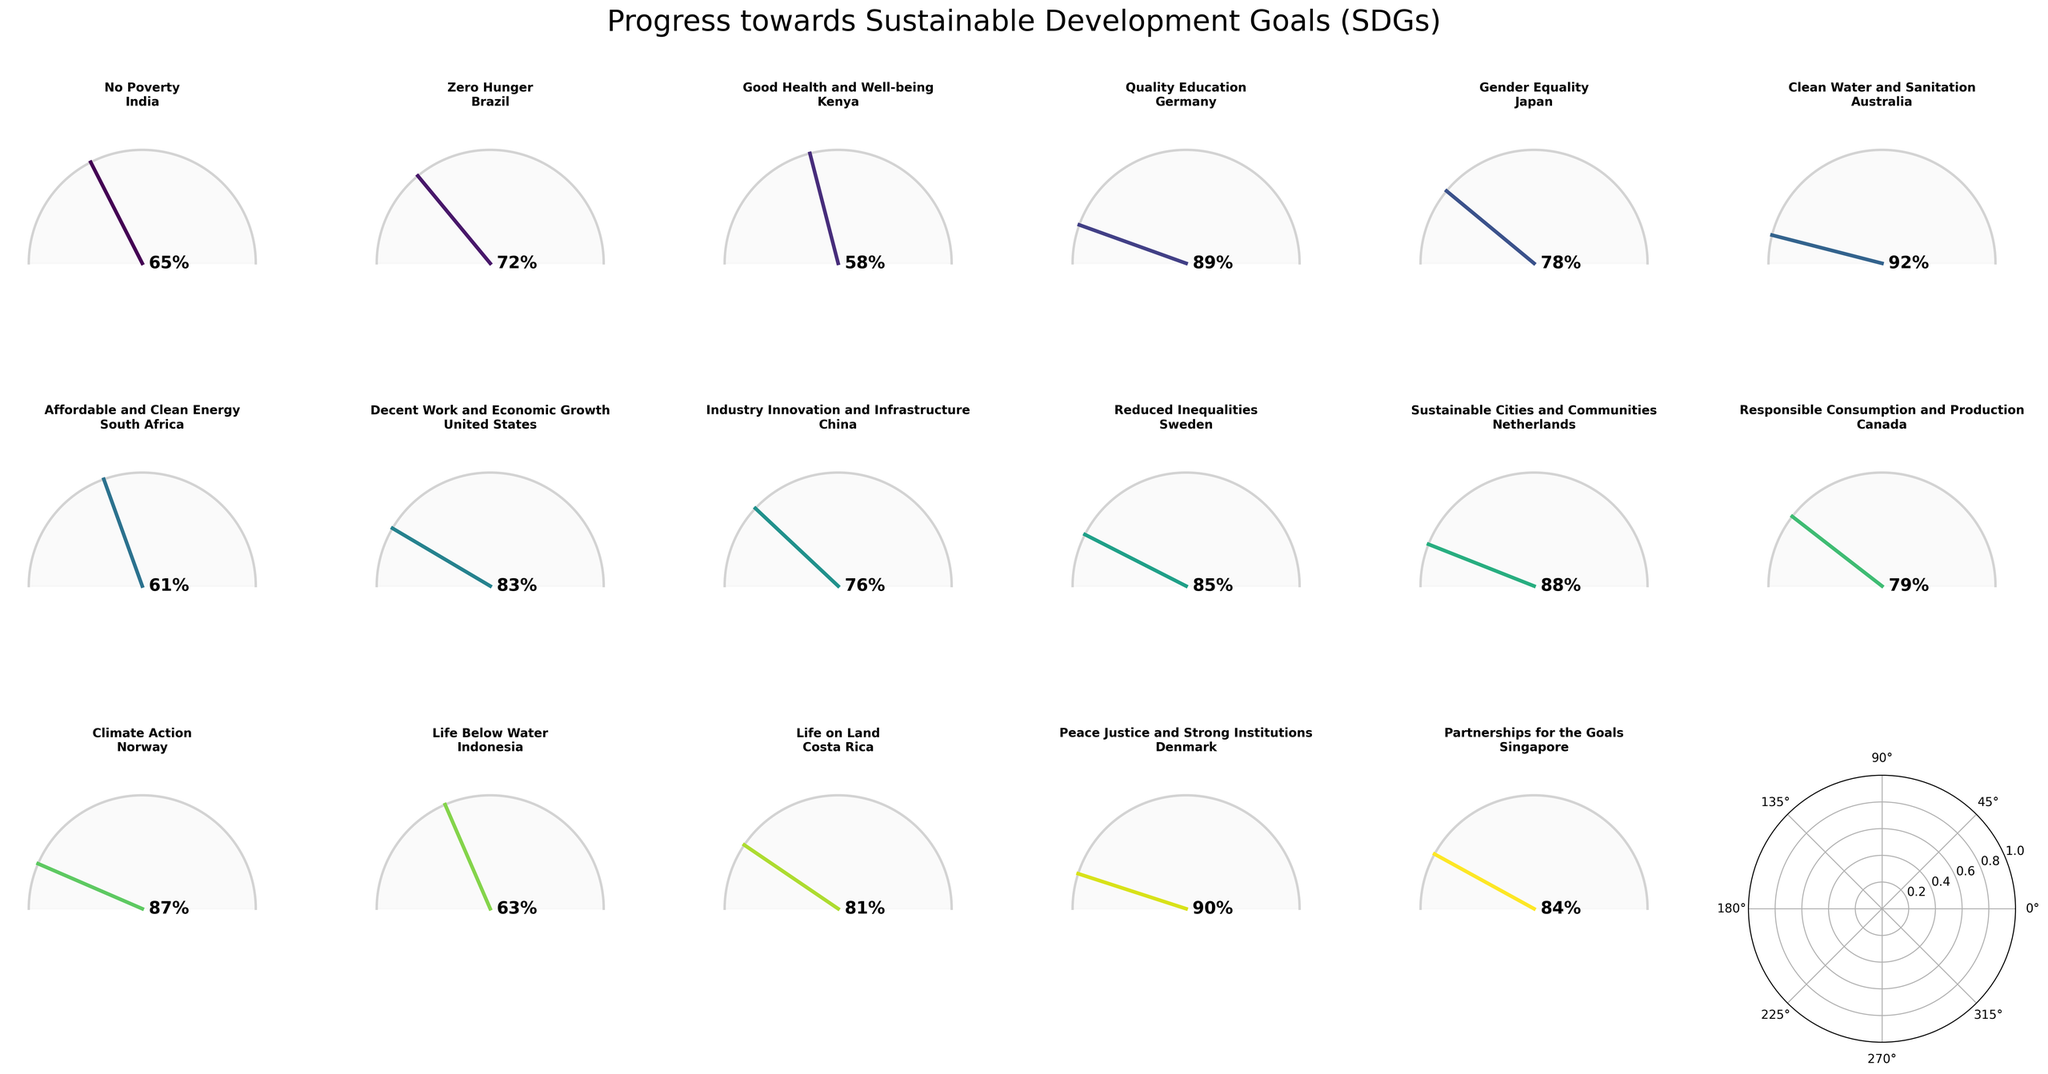Which country has made the most progress towards Quality Education? The figure shows each country and their corresponding SDG progress. By looking at the gauge chart for "Quality Education," we can see that Germany has the highest progress value of 89%.
Answer: Germany What is the combined progress percentage for Australia and Netherlands in their respective SDGs? Australia's SDG is "Clean Water and Sanitation" with a progress of 92% and Netherlands' SDG is "Sustainable Cities and Communities" with a progress of 88%. Summing these percentages gives us 92% + 88% = 180%.
Answer: 180% Which SDG and country combination has the lowest progress? By comparing all gauge charts, the lowest progress is found in Kenya for the SDG "Good Health and Well-being" with a progress percentage of 58%.
Answer: Kenya, Good Health and Well-being How many countries have a progress percentage of 80% or higher towards their respective SDGs? By examining the gauge charts, we see that Germany, Japan, United States, Sweden, Netherlands, Canada, Costa Rica, Denmark, and Singapore have progress percentages of 89%, 78%, 83%, 85%, 88%, 79%, 81%, 90%, and 84%, respectively. Filtering those 80% or higher we get Germany, United States, Sweden, Netherlands, Costa Rica, Denmark and Singapore. In total, there are 7 countries.
Answer: 7 Which country has a higher progress percentage: China or South Africa? China is responsible for "Industry Innovation and Infrastructure" with a progress of 76%, while South Africa is responsible for "Affordable and Clean Energy" with a progress of 61%. Since 76% (China) is greater than 61% (South Africa), China has a higher progress percentage.
Answer: China What is the average progress percentage for the countries focused on environmental SDGs such as "Life Below Water," "Life on Land," and "Climate Action"? The countries for these SDGs are Indonesia (63% for "Life Below Water"), Costa Rica (81% for "Life on Land"), and Norway (87% for "Climate Action"). Adding these percentages gives: 63% + 81% + 87% = 231%. The average is thus 231% / 3 = 77%.
Answer: 77% Which country is making better progress towards their SDG: Brazil or Japan? Brazil is focused on "Zero Hunger" with a progress of 72%, while Japan is focused on "Gender Equality" with a progress of 78%. Since 78% (Japan) is greater than 72% (Brazil), Japan is making better progress towards their SDG.
Answer: Japan What is the median progress percentage among all the countries' SDGs? Listing the progress percentages we have: 58, 61, 63, 65, 72, 76, 78, 79, 81, 83, 84, 85, 87, 88, 89, 90, and 92. Sorting them: 58, 61, 63, 65, 72, 76, 78, 79, 81, 83, 84, 85, 87, 88, 89, 90, and 92. The median is the middle value, thus (81+83)/2 = 82.
Answer: 82 